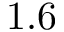<formula> <loc_0><loc_0><loc_500><loc_500>1 . 6</formula> 